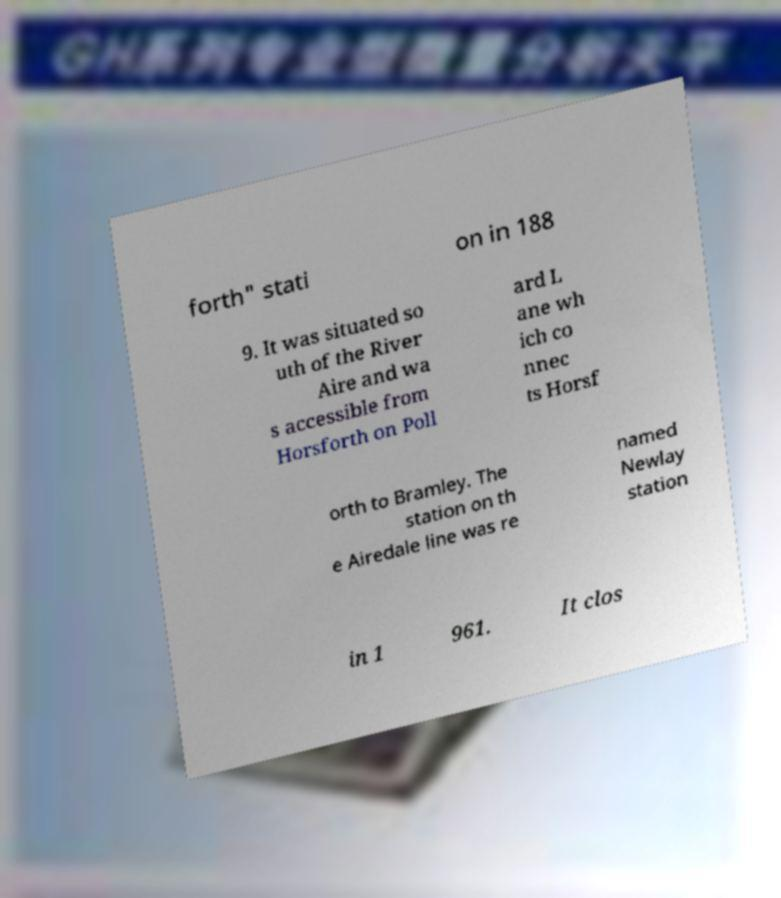Please identify and transcribe the text found in this image. forth" stati on in 188 9. It was situated so uth of the River Aire and wa s accessible from Horsforth on Poll ard L ane wh ich co nnec ts Horsf orth to Bramley. The station on th e Airedale line was re named Newlay station in 1 961. It clos 